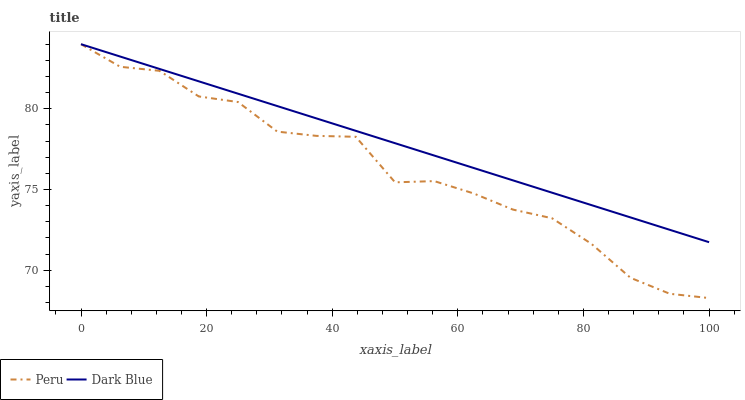Does Peru have the minimum area under the curve?
Answer yes or no. Yes. Does Dark Blue have the maximum area under the curve?
Answer yes or no. Yes. Does Peru have the maximum area under the curve?
Answer yes or no. No. Is Dark Blue the smoothest?
Answer yes or no. Yes. Is Peru the roughest?
Answer yes or no. Yes. Is Peru the smoothest?
Answer yes or no. No. Does Peru have the lowest value?
Answer yes or no. Yes. Does Peru have the highest value?
Answer yes or no. Yes. Does Peru intersect Dark Blue?
Answer yes or no. Yes. Is Peru less than Dark Blue?
Answer yes or no. No. Is Peru greater than Dark Blue?
Answer yes or no. No. 